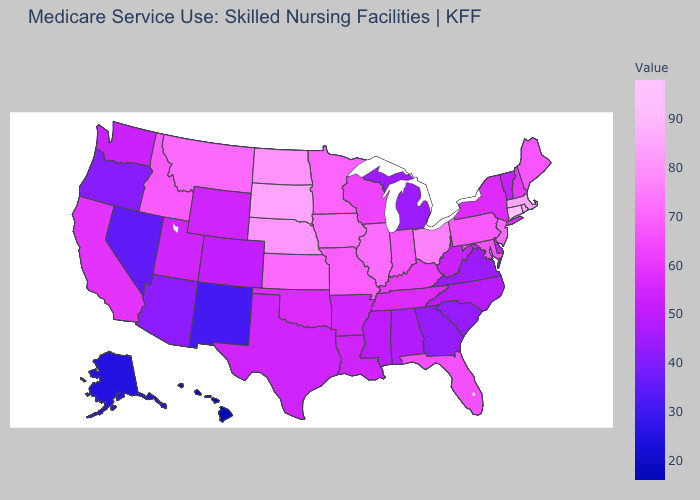Does the map have missing data?
Concise answer only. No. Is the legend a continuous bar?
Keep it brief. Yes. Does the map have missing data?
Keep it brief. No. Is the legend a continuous bar?
Concise answer only. Yes. Does Pennsylvania have a lower value than Nebraska?
Be succinct. Yes. Does North Carolina have the highest value in the South?
Write a very short answer. No. 